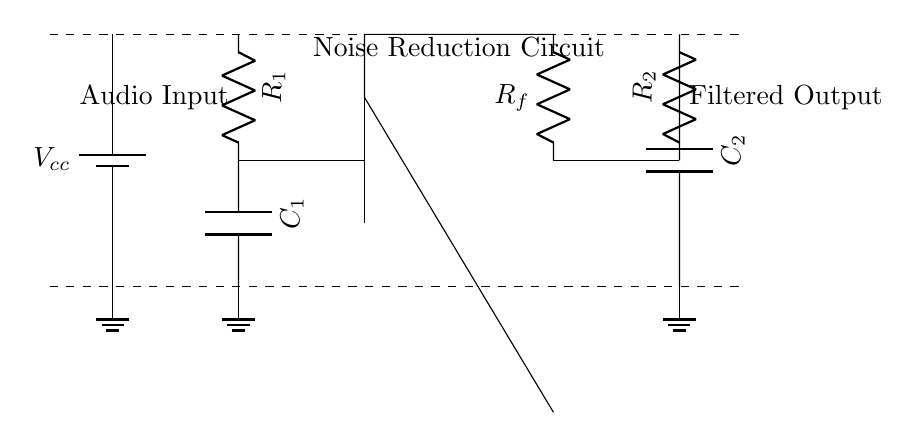What is the input stage component? The input stage consists of a resistor and a capacitor. The resistor is labeled R1 and the capacitor is labeled C1.
Answer: R1 and C1 What role does the operational amplifier play in this circuit? The operational amplifier amplifies the audio signal after it passes through the input stage, allowing for noise reduction in the output.
Answer: Amplify What components are used in the feedback network? The feedback network consists of a resistor denoted as Rf that connects the output of the operational amplifier to its inverting input.
Answer: Rf How many capacitors are present in the circuit? There are two capacitors present, labeled C1 and C2, one in the input stage and the other in the output stage.
Answer: Two What is the function of the noise reduction circuit? The function is to filter unwanted noise from the audio signal, enhancing the quality of the output sound.
Answer: Filter What happens to the audio signal after the operational amplifier? After the operational amplifier, the audio signal is filtered through the output stage which includes resistor R2 and capacitor C2 before being output.
Answer: Filtered Output What is the voltage supply in this circuit? The circuit is powered by a voltage supply denoted as Vcc.
Answer: Vcc 